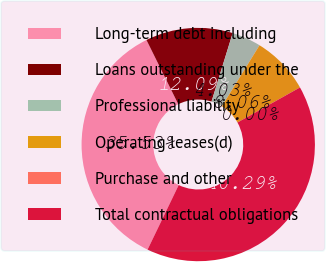Convert chart to OTSL. <chart><loc_0><loc_0><loc_500><loc_500><pie_chart><fcel>Long-term debt including<fcel>Loans outstanding under the<fcel>Professional liability<fcel>Operating leases(d)<fcel>Purchase and other<fcel>Total contractual obligations<nl><fcel>35.53%<fcel>12.09%<fcel>4.03%<fcel>8.06%<fcel>0.0%<fcel>40.29%<nl></chart> 